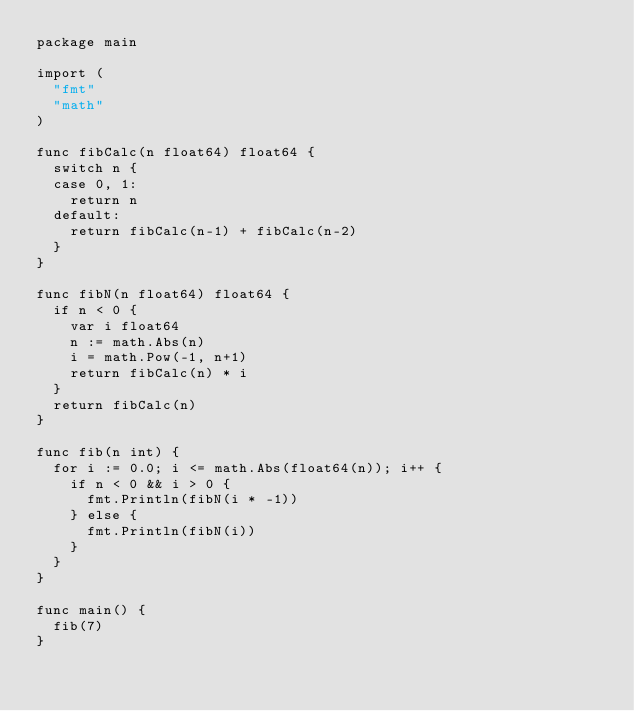<code> <loc_0><loc_0><loc_500><loc_500><_Go_>package main

import (
	"fmt"
	"math"
)

func fibCalc(n float64) float64 {
	switch n {
	case 0, 1:
		return n
	default:
		return fibCalc(n-1) + fibCalc(n-2)
	}
}

func fibN(n float64) float64 {
	if n < 0 {
		var i float64
		n := math.Abs(n)
		i = math.Pow(-1, n+1)
		return fibCalc(n) * i
	}
	return fibCalc(n)
}

func fib(n int) {
	for i := 0.0; i <= math.Abs(float64(n)); i++ {
		if n < 0 && i > 0 {
			fmt.Println(fibN(i * -1))
		} else {
			fmt.Println(fibN(i))
		}
	}
}

func main() {
	fib(7)
}
</code> 